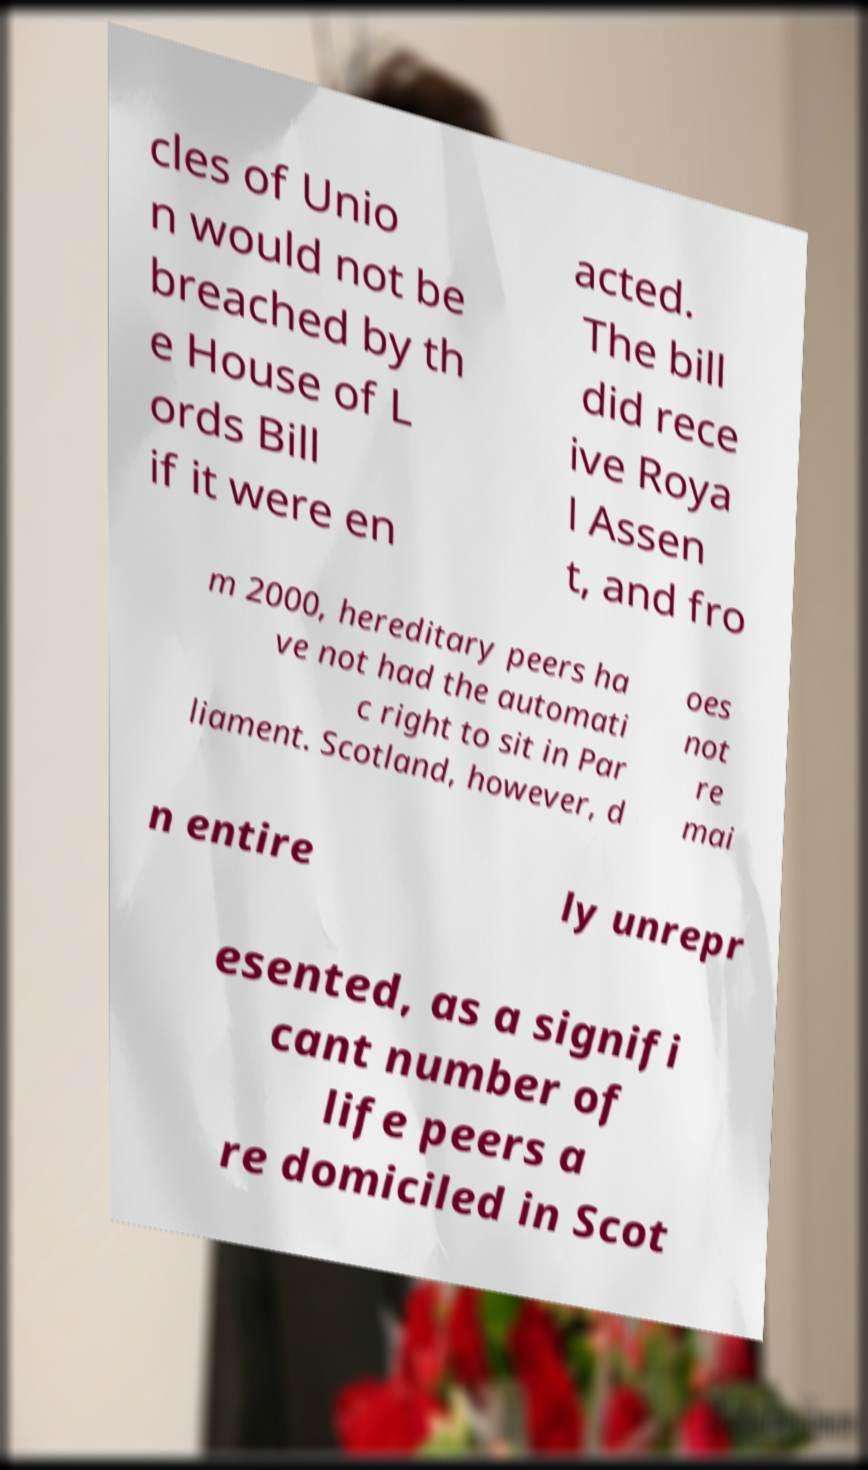For documentation purposes, I need the text within this image transcribed. Could you provide that? cles of Unio n would not be breached by th e House of L ords Bill if it were en acted. The bill did rece ive Roya l Assen t, and fro m 2000, hereditary peers ha ve not had the automati c right to sit in Par liament. Scotland, however, d oes not re mai n entire ly unrepr esented, as a signifi cant number of life peers a re domiciled in Scot 